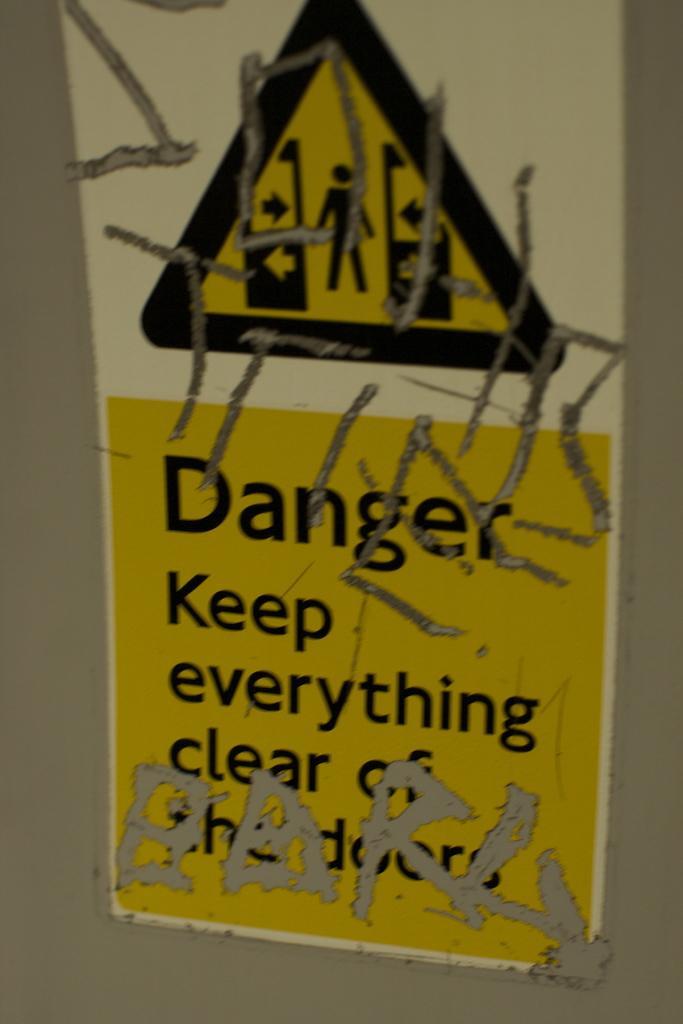In one or two sentences, can you explain what this image depicts? In this picture we can see a poster on the wall and on the poster there is a symbol of a person and arrows, and on the poster it is written something. 